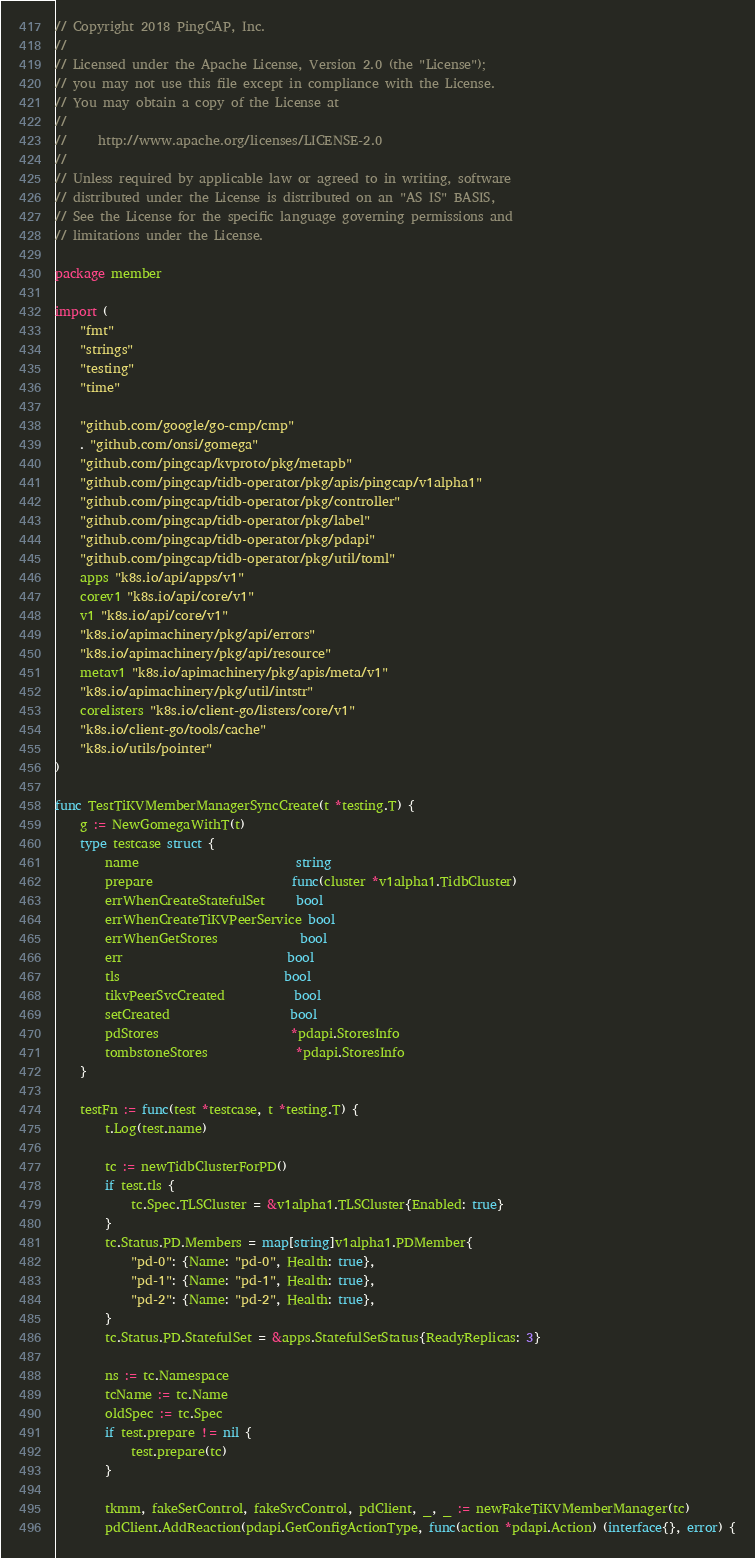Convert code to text. <code><loc_0><loc_0><loc_500><loc_500><_Go_>// Copyright 2018 PingCAP, Inc.
//
// Licensed under the Apache License, Version 2.0 (the "License");
// you may not use this file except in compliance with the License.
// You may obtain a copy of the License at
//
//     http://www.apache.org/licenses/LICENSE-2.0
//
// Unless required by applicable law or agreed to in writing, software
// distributed under the License is distributed on an "AS IS" BASIS,
// See the License for the specific language governing permissions and
// limitations under the License.

package member

import (
	"fmt"
	"strings"
	"testing"
	"time"

	"github.com/google/go-cmp/cmp"
	. "github.com/onsi/gomega"
	"github.com/pingcap/kvproto/pkg/metapb"
	"github.com/pingcap/tidb-operator/pkg/apis/pingcap/v1alpha1"
	"github.com/pingcap/tidb-operator/pkg/controller"
	"github.com/pingcap/tidb-operator/pkg/label"
	"github.com/pingcap/tidb-operator/pkg/pdapi"
	"github.com/pingcap/tidb-operator/pkg/util/toml"
	apps "k8s.io/api/apps/v1"
	corev1 "k8s.io/api/core/v1"
	v1 "k8s.io/api/core/v1"
	"k8s.io/apimachinery/pkg/api/errors"
	"k8s.io/apimachinery/pkg/api/resource"
	metav1 "k8s.io/apimachinery/pkg/apis/meta/v1"
	"k8s.io/apimachinery/pkg/util/intstr"
	corelisters "k8s.io/client-go/listers/core/v1"
	"k8s.io/client-go/tools/cache"
	"k8s.io/utils/pointer"
)

func TestTiKVMemberManagerSyncCreate(t *testing.T) {
	g := NewGomegaWithT(t)
	type testcase struct {
		name                         string
		prepare                      func(cluster *v1alpha1.TidbCluster)
		errWhenCreateStatefulSet     bool
		errWhenCreateTiKVPeerService bool
		errWhenGetStores             bool
		err                          bool
		tls                          bool
		tikvPeerSvcCreated           bool
		setCreated                   bool
		pdStores                     *pdapi.StoresInfo
		tombstoneStores              *pdapi.StoresInfo
	}

	testFn := func(test *testcase, t *testing.T) {
		t.Log(test.name)

		tc := newTidbClusterForPD()
		if test.tls {
			tc.Spec.TLSCluster = &v1alpha1.TLSCluster{Enabled: true}
		}
		tc.Status.PD.Members = map[string]v1alpha1.PDMember{
			"pd-0": {Name: "pd-0", Health: true},
			"pd-1": {Name: "pd-1", Health: true},
			"pd-2": {Name: "pd-2", Health: true},
		}
		tc.Status.PD.StatefulSet = &apps.StatefulSetStatus{ReadyReplicas: 3}

		ns := tc.Namespace
		tcName := tc.Name
		oldSpec := tc.Spec
		if test.prepare != nil {
			test.prepare(tc)
		}

		tkmm, fakeSetControl, fakeSvcControl, pdClient, _, _ := newFakeTiKVMemberManager(tc)
		pdClient.AddReaction(pdapi.GetConfigActionType, func(action *pdapi.Action) (interface{}, error) {</code> 